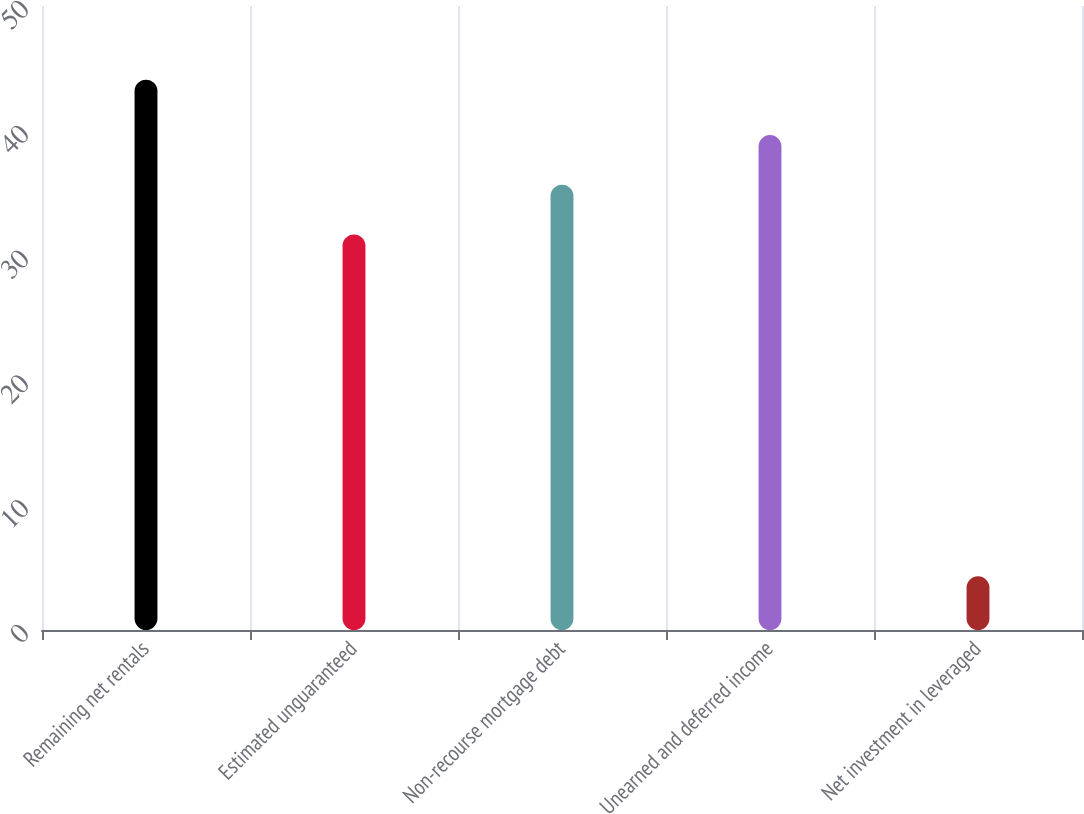<chart> <loc_0><loc_0><loc_500><loc_500><bar_chart><fcel>Remaining net rentals<fcel>Estimated unguaranteed<fcel>Non-recourse mortgage debt<fcel>Unearned and deferred income<fcel>Net investment in leveraged<nl><fcel>44.1<fcel>31.7<fcel>35.68<fcel>39.66<fcel>4.3<nl></chart> 